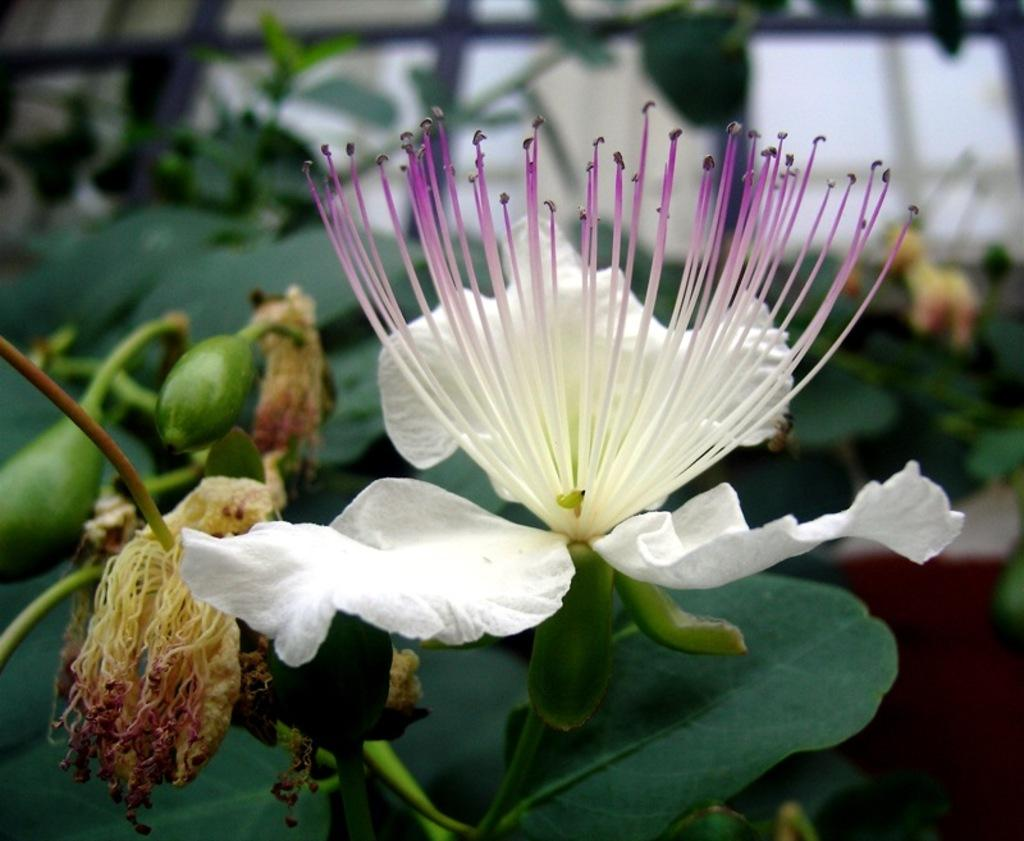What type of flower is in the image? There is a white flower in the image. Where is the flower located in the image? The flower is in the middle of the image. What can be seen in the background of the image? Fruits, leaves, and stems are visible in the background of the image. What type of jewel is hanging from the flower in the image? There is no jewel present in the image; it features a white flower with no additional adornments. 